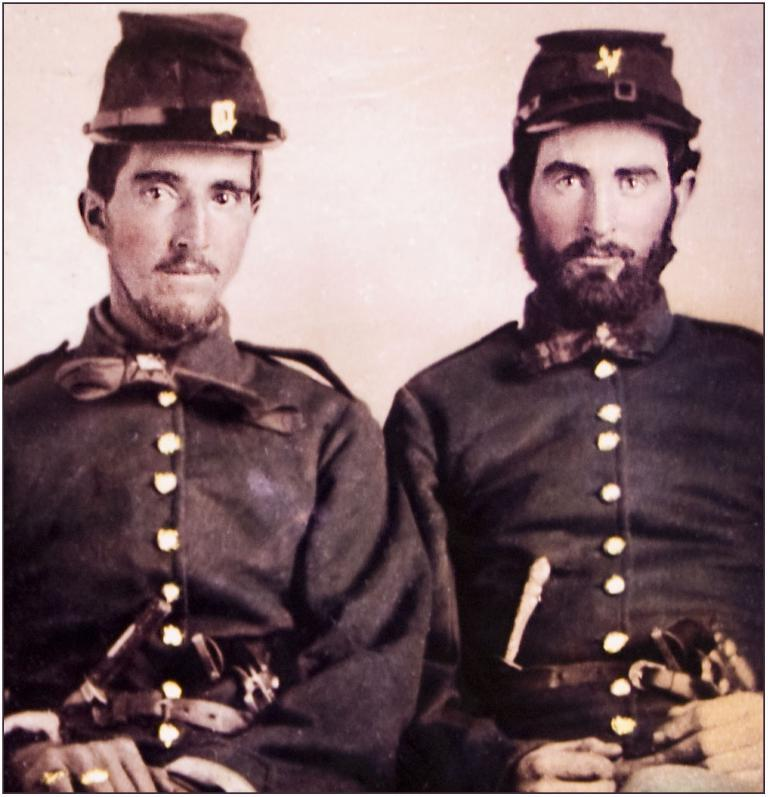How many people are in the image? There are two men in the image. What are the men wearing? Both men are wearing the same dress. What are the men doing in the image? The men are sitting on chairs. What can be seen in the background of the image? There is a wall in the background of the image. What is the skin color of the men in the image? The provided facts do not mention the skin color of the men, so it cannot be determined from the image. What is the tendency of the men in the image? The provided facts do not mention any specific tendencies of the men, so it cannot be determined from the image. 